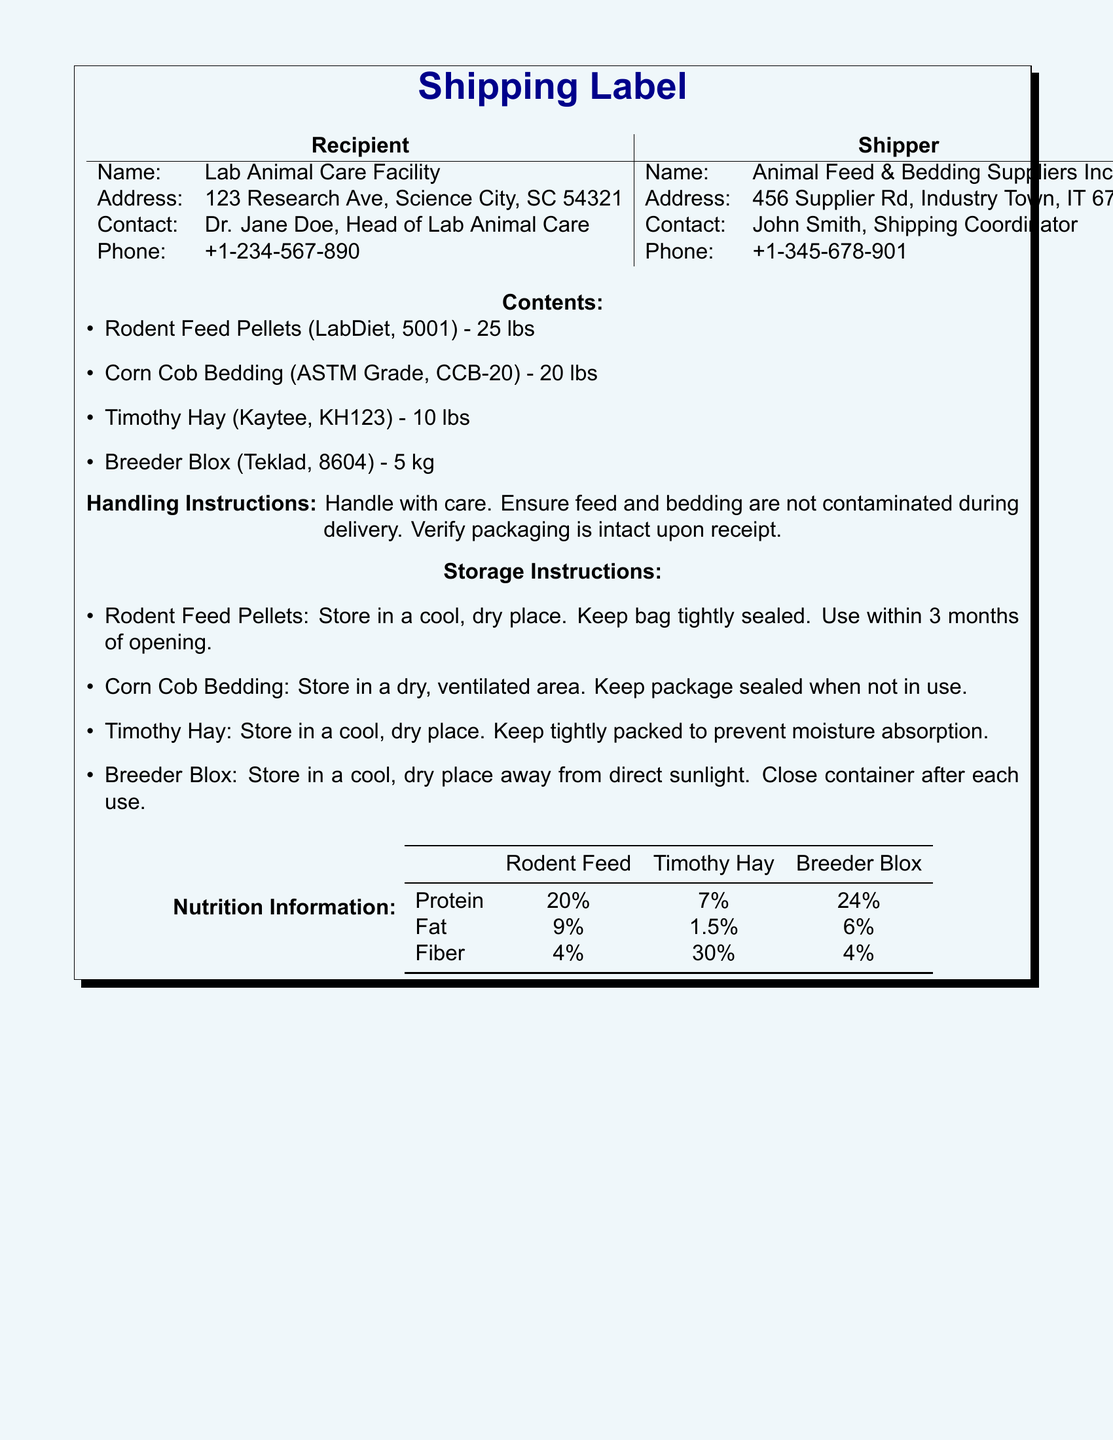What is the name of the recipient? The recipient's name is listed in the document as the Lab Animal Care Facility.
Answer: Lab Animal Care Facility What is the address of the shipper? The document provides the shipper's address as 456 Supplier Rd, Industry Town, IT 67890.
Answer: 456 Supplier Rd, Industry Town, IT 67890 How many pounds of Corn Cob Bedding are included? The contents section states that Corn Cob Bedding weighs 20 lbs.
Answer: 20 lbs What is the protein percentage in Rodent Feed Pellets? The nutrition information section indicates that Rodent Feed Pellets contain 20% protein.
Answer: 20% What are the storage instructions for Breeder Blox? The document specifies storing Breeder Blox in a cool, dry place away from direct sunlight and closing the container after each use.
Answer: Store in a cool, dry place away from direct sunlight What is the total weight of all items listed? The total weight can be derived from the weights of the listed items: 25 lbs (Rodent Feed) + 20 lbs (Corn Cob) + 10 lbs (Timothy Hay) + 5 kg (Breeder Blox converted to lbs) = 55 lbs.
Answer: 55 lbs How many contacts are listed for the recipient? The document provides one contact person for the recipient, Dr. Jane Doe.
Answer: One What is the fat percentage in Breeder Blox? The nutrition information table shows that Breeder Blox contains 6% fat.
Answer: 6% What item has the highest fiber percentage? The information in the document indicates that Timothy Hay has the highest fiber percentage at 30%.
Answer: Timothy Hay Are there any handling instructions? The document explicitly states to handle with care and ensure no contamination occurs during delivery.
Answer: Yes, handle with care 